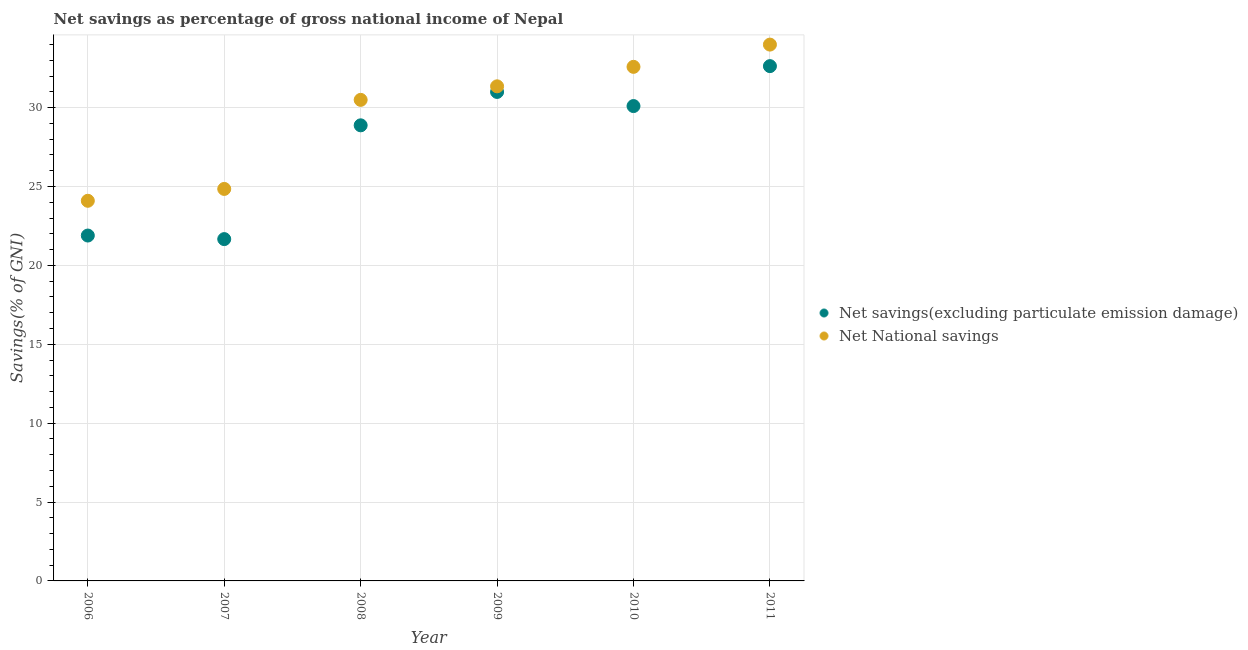How many different coloured dotlines are there?
Make the answer very short. 2. Is the number of dotlines equal to the number of legend labels?
Your answer should be compact. Yes. What is the net savings(excluding particulate emission damage) in 2007?
Ensure brevity in your answer.  21.66. Across all years, what is the maximum net national savings?
Keep it short and to the point. 33.99. Across all years, what is the minimum net savings(excluding particulate emission damage)?
Provide a succinct answer. 21.66. What is the total net savings(excluding particulate emission damage) in the graph?
Make the answer very short. 166.14. What is the difference between the net savings(excluding particulate emission damage) in 2007 and that in 2011?
Your answer should be very brief. -10.96. What is the difference between the net national savings in 2007 and the net savings(excluding particulate emission damage) in 2006?
Make the answer very short. 2.95. What is the average net national savings per year?
Your response must be concise. 29.56. In the year 2007, what is the difference between the net savings(excluding particulate emission damage) and net national savings?
Provide a succinct answer. -3.18. In how many years, is the net savings(excluding particulate emission damage) greater than 9 %?
Your answer should be compact. 6. What is the ratio of the net national savings in 2007 to that in 2010?
Your answer should be compact. 0.76. Is the difference between the net national savings in 2007 and 2009 greater than the difference between the net savings(excluding particulate emission damage) in 2007 and 2009?
Your answer should be compact. Yes. What is the difference between the highest and the second highest net national savings?
Provide a short and direct response. 1.41. What is the difference between the highest and the lowest net national savings?
Your answer should be compact. 9.9. In how many years, is the net savings(excluding particulate emission damage) greater than the average net savings(excluding particulate emission damage) taken over all years?
Your response must be concise. 4. Is the sum of the net national savings in 2008 and 2010 greater than the maximum net savings(excluding particulate emission damage) across all years?
Provide a short and direct response. Yes. Is the net national savings strictly greater than the net savings(excluding particulate emission damage) over the years?
Provide a short and direct response. Yes. Is the net national savings strictly less than the net savings(excluding particulate emission damage) over the years?
Ensure brevity in your answer.  No. Does the graph contain any zero values?
Your response must be concise. No. Does the graph contain grids?
Give a very brief answer. Yes. Where does the legend appear in the graph?
Your answer should be very brief. Center right. How are the legend labels stacked?
Provide a succinct answer. Vertical. What is the title of the graph?
Provide a succinct answer. Net savings as percentage of gross national income of Nepal. Does "Highest 20% of population" appear as one of the legend labels in the graph?
Offer a very short reply. No. What is the label or title of the X-axis?
Give a very brief answer. Year. What is the label or title of the Y-axis?
Your response must be concise. Savings(% of GNI). What is the Savings(% of GNI) of Net savings(excluding particulate emission damage) in 2006?
Keep it short and to the point. 21.89. What is the Savings(% of GNI) of Net National savings in 2006?
Offer a terse response. 24.09. What is the Savings(% of GNI) in Net savings(excluding particulate emission damage) in 2007?
Offer a very short reply. 21.66. What is the Savings(% of GNI) in Net National savings in 2007?
Give a very brief answer. 24.84. What is the Savings(% of GNI) in Net savings(excluding particulate emission damage) in 2008?
Make the answer very short. 28.87. What is the Savings(% of GNI) of Net National savings in 2008?
Keep it short and to the point. 30.49. What is the Savings(% of GNI) in Net savings(excluding particulate emission damage) in 2009?
Give a very brief answer. 30.99. What is the Savings(% of GNI) of Net National savings in 2009?
Give a very brief answer. 31.35. What is the Savings(% of GNI) in Net savings(excluding particulate emission damage) in 2010?
Ensure brevity in your answer.  30.1. What is the Savings(% of GNI) of Net National savings in 2010?
Ensure brevity in your answer.  32.58. What is the Savings(% of GNI) of Net savings(excluding particulate emission damage) in 2011?
Keep it short and to the point. 32.63. What is the Savings(% of GNI) in Net National savings in 2011?
Your answer should be compact. 33.99. Across all years, what is the maximum Savings(% of GNI) of Net savings(excluding particulate emission damage)?
Offer a very short reply. 32.63. Across all years, what is the maximum Savings(% of GNI) of Net National savings?
Your answer should be compact. 33.99. Across all years, what is the minimum Savings(% of GNI) in Net savings(excluding particulate emission damage)?
Keep it short and to the point. 21.66. Across all years, what is the minimum Savings(% of GNI) of Net National savings?
Your answer should be very brief. 24.09. What is the total Savings(% of GNI) in Net savings(excluding particulate emission damage) in the graph?
Ensure brevity in your answer.  166.14. What is the total Savings(% of GNI) of Net National savings in the graph?
Your answer should be very brief. 177.34. What is the difference between the Savings(% of GNI) of Net savings(excluding particulate emission damage) in 2006 and that in 2007?
Make the answer very short. 0.23. What is the difference between the Savings(% of GNI) in Net National savings in 2006 and that in 2007?
Your response must be concise. -0.75. What is the difference between the Savings(% of GNI) of Net savings(excluding particulate emission damage) in 2006 and that in 2008?
Make the answer very short. -6.99. What is the difference between the Savings(% of GNI) of Net National savings in 2006 and that in 2008?
Offer a very short reply. -6.4. What is the difference between the Savings(% of GNI) of Net savings(excluding particulate emission damage) in 2006 and that in 2009?
Make the answer very short. -9.1. What is the difference between the Savings(% of GNI) of Net National savings in 2006 and that in 2009?
Give a very brief answer. -7.25. What is the difference between the Savings(% of GNI) in Net savings(excluding particulate emission damage) in 2006 and that in 2010?
Provide a succinct answer. -8.21. What is the difference between the Savings(% of GNI) in Net National savings in 2006 and that in 2010?
Your answer should be very brief. -8.49. What is the difference between the Savings(% of GNI) in Net savings(excluding particulate emission damage) in 2006 and that in 2011?
Make the answer very short. -10.74. What is the difference between the Savings(% of GNI) in Net National savings in 2006 and that in 2011?
Your response must be concise. -9.9. What is the difference between the Savings(% of GNI) of Net savings(excluding particulate emission damage) in 2007 and that in 2008?
Provide a succinct answer. -7.21. What is the difference between the Savings(% of GNI) of Net National savings in 2007 and that in 2008?
Your answer should be very brief. -5.64. What is the difference between the Savings(% of GNI) of Net savings(excluding particulate emission damage) in 2007 and that in 2009?
Provide a succinct answer. -9.33. What is the difference between the Savings(% of GNI) of Net National savings in 2007 and that in 2009?
Keep it short and to the point. -6.5. What is the difference between the Savings(% of GNI) in Net savings(excluding particulate emission damage) in 2007 and that in 2010?
Make the answer very short. -8.43. What is the difference between the Savings(% of GNI) of Net National savings in 2007 and that in 2010?
Your answer should be compact. -7.74. What is the difference between the Savings(% of GNI) in Net savings(excluding particulate emission damage) in 2007 and that in 2011?
Make the answer very short. -10.96. What is the difference between the Savings(% of GNI) of Net National savings in 2007 and that in 2011?
Ensure brevity in your answer.  -9.15. What is the difference between the Savings(% of GNI) of Net savings(excluding particulate emission damage) in 2008 and that in 2009?
Provide a succinct answer. -2.12. What is the difference between the Savings(% of GNI) in Net National savings in 2008 and that in 2009?
Give a very brief answer. -0.86. What is the difference between the Savings(% of GNI) of Net savings(excluding particulate emission damage) in 2008 and that in 2010?
Offer a terse response. -1.22. What is the difference between the Savings(% of GNI) in Net National savings in 2008 and that in 2010?
Offer a very short reply. -2.09. What is the difference between the Savings(% of GNI) of Net savings(excluding particulate emission damage) in 2008 and that in 2011?
Give a very brief answer. -3.75. What is the difference between the Savings(% of GNI) in Net National savings in 2008 and that in 2011?
Make the answer very short. -3.5. What is the difference between the Savings(% of GNI) in Net savings(excluding particulate emission damage) in 2009 and that in 2010?
Your answer should be compact. 0.89. What is the difference between the Savings(% of GNI) in Net National savings in 2009 and that in 2010?
Offer a very short reply. -1.23. What is the difference between the Savings(% of GNI) in Net savings(excluding particulate emission damage) in 2009 and that in 2011?
Provide a succinct answer. -1.64. What is the difference between the Savings(% of GNI) in Net National savings in 2009 and that in 2011?
Your answer should be very brief. -2.64. What is the difference between the Savings(% of GNI) in Net savings(excluding particulate emission damage) in 2010 and that in 2011?
Make the answer very short. -2.53. What is the difference between the Savings(% of GNI) in Net National savings in 2010 and that in 2011?
Your answer should be very brief. -1.41. What is the difference between the Savings(% of GNI) in Net savings(excluding particulate emission damage) in 2006 and the Savings(% of GNI) in Net National savings in 2007?
Make the answer very short. -2.95. What is the difference between the Savings(% of GNI) of Net savings(excluding particulate emission damage) in 2006 and the Savings(% of GNI) of Net National savings in 2008?
Your answer should be very brief. -8.6. What is the difference between the Savings(% of GNI) in Net savings(excluding particulate emission damage) in 2006 and the Savings(% of GNI) in Net National savings in 2009?
Give a very brief answer. -9.46. What is the difference between the Savings(% of GNI) in Net savings(excluding particulate emission damage) in 2006 and the Savings(% of GNI) in Net National savings in 2010?
Your answer should be compact. -10.69. What is the difference between the Savings(% of GNI) in Net savings(excluding particulate emission damage) in 2006 and the Savings(% of GNI) in Net National savings in 2011?
Your answer should be compact. -12.1. What is the difference between the Savings(% of GNI) in Net savings(excluding particulate emission damage) in 2007 and the Savings(% of GNI) in Net National savings in 2008?
Your answer should be very brief. -8.82. What is the difference between the Savings(% of GNI) in Net savings(excluding particulate emission damage) in 2007 and the Savings(% of GNI) in Net National savings in 2009?
Your answer should be compact. -9.68. What is the difference between the Savings(% of GNI) in Net savings(excluding particulate emission damage) in 2007 and the Savings(% of GNI) in Net National savings in 2010?
Provide a short and direct response. -10.92. What is the difference between the Savings(% of GNI) of Net savings(excluding particulate emission damage) in 2007 and the Savings(% of GNI) of Net National savings in 2011?
Ensure brevity in your answer.  -12.33. What is the difference between the Savings(% of GNI) of Net savings(excluding particulate emission damage) in 2008 and the Savings(% of GNI) of Net National savings in 2009?
Your response must be concise. -2.47. What is the difference between the Savings(% of GNI) of Net savings(excluding particulate emission damage) in 2008 and the Savings(% of GNI) of Net National savings in 2010?
Provide a succinct answer. -3.71. What is the difference between the Savings(% of GNI) in Net savings(excluding particulate emission damage) in 2008 and the Savings(% of GNI) in Net National savings in 2011?
Your response must be concise. -5.12. What is the difference between the Savings(% of GNI) in Net savings(excluding particulate emission damage) in 2009 and the Savings(% of GNI) in Net National savings in 2010?
Make the answer very short. -1.59. What is the difference between the Savings(% of GNI) in Net savings(excluding particulate emission damage) in 2009 and the Savings(% of GNI) in Net National savings in 2011?
Offer a very short reply. -3. What is the difference between the Savings(% of GNI) in Net savings(excluding particulate emission damage) in 2010 and the Savings(% of GNI) in Net National savings in 2011?
Your answer should be compact. -3.9. What is the average Savings(% of GNI) of Net savings(excluding particulate emission damage) per year?
Provide a succinct answer. 27.69. What is the average Savings(% of GNI) of Net National savings per year?
Make the answer very short. 29.56. In the year 2006, what is the difference between the Savings(% of GNI) of Net savings(excluding particulate emission damage) and Savings(% of GNI) of Net National savings?
Make the answer very short. -2.2. In the year 2007, what is the difference between the Savings(% of GNI) in Net savings(excluding particulate emission damage) and Savings(% of GNI) in Net National savings?
Your answer should be very brief. -3.18. In the year 2008, what is the difference between the Savings(% of GNI) in Net savings(excluding particulate emission damage) and Savings(% of GNI) in Net National savings?
Ensure brevity in your answer.  -1.61. In the year 2009, what is the difference between the Savings(% of GNI) of Net savings(excluding particulate emission damage) and Savings(% of GNI) of Net National savings?
Provide a short and direct response. -0.36. In the year 2010, what is the difference between the Savings(% of GNI) of Net savings(excluding particulate emission damage) and Savings(% of GNI) of Net National savings?
Give a very brief answer. -2.49. In the year 2011, what is the difference between the Savings(% of GNI) in Net savings(excluding particulate emission damage) and Savings(% of GNI) in Net National savings?
Provide a short and direct response. -1.36. What is the ratio of the Savings(% of GNI) of Net savings(excluding particulate emission damage) in 2006 to that in 2007?
Give a very brief answer. 1.01. What is the ratio of the Savings(% of GNI) of Net National savings in 2006 to that in 2007?
Offer a very short reply. 0.97. What is the ratio of the Savings(% of GNI) in Net savings(excluding particulate emission damage) in 2006 to that in 2008?
Give a very brief answer. 0.76. What is the ratio of the Savings(% of GNI) in Net National savings in 2006 to that in 2008?
Your answer should be compact. 0.79. What is the ratio of the Savings(% of GNI) of Net savings(excluding particulate emission damage) in 2006 to that in 2009?
Your response must be concise. 0.71. What is the ratio of the Savings(% of GNI) of Net National savings in 2006 to that in 2009?
Offer a very short reply. 0.77. What is the ratio of the Savings(% of GNI) of Net savings(excluding particulate emission damage) in 2006 to that in 2010?
Offer a very short reply. 0.73. What is the ratio of the Savings(% of GNI) in Net National savings in 2006 to that in 2010?
Provide a succinct answer. 0.74. What is the ratio of the Savings(% of GNI) of Net savings(excluding particulate emission damage) in 2006 to that in 2011?
Provide a succinct answer. 0.67. What is the ratio of the Savings(% of GNI) in Net National savings in 2006 to that in 2011?
Keep it short and to the point. 0.71. What is the ratio of the Savings(% of GNI) in Net savings(excluding particulate emission damage) in 2007 to that in 2008?
Your answer should be compact. 0.75. What is the ratio of the Savings(% of GNI) of Net National savings in 2007 to that in 2008?
Offer a very short reply. 0.81. What is the ratio of the Savings(% of GNI) in Net savings(excluding particulate emission damage) in 2007 to that in 2009?
Keep it short and to the point. 0.7. What is the ratio of the Savings(% of GNI) in Net National savings in 2007 to that in 2009?
Ensure brevity in your answer.  0.79. What is the ratio of the Savings(% of GNI) of Net savings(excluding particulate emission damage) in 2007 to that in 2010?
Provide a succinct answer. 0.72. What is the ratio of the Savings(% of GNI) in Net National savings in 2007 to that in 2010?
Keep it short and to the point. 0.76. What is the ratio of the Savings(% of GNI) of Net savings(excluding particulate emission damage) in 2007 to that in 2011?
Your answer should be very brief. 0.66. What is the ratio of the Savings(% of GNI) in Net National savings in 2007 to that in 2011?
Give a very brief answer. 0.73. What is the ratio of the Savings(% of GNI) of Net savings(excluding particulate emission damage) in 2008 to that in 2009?
Give a very brief answer. 0.93. What is the ratio of the Savings(% of GNI) of Net National savings in 2008 to that in 2009?
Keep it short and to the point. 0.97. What is the ratio of the Savings(% of GNI) of Net savings(excluding particulate emission damage) in 2008 to that in 2010?
Your response must be concise. 0.96. What is the ratio of the Savings(% of GNI) of Net National savings in 2008 to that in 2010?
Your answer should be compact. 0.94. What is the ratio of the Savings(% of GNI) of Net savings(excluding particulate emission damage) in 2008 to that in 2011?
Make the answer very short. 0.89. What is the ratio of the Savings(% of GNI) in Net National savings in 2008 to that in 2011?
Provide a succinct answer. 0.9. What is the ratio of the Savings(% of GNI) of Net savings(excluding particulate emission damage) in 2009 to that in 2010?
Provide a short and direct response. 1.03. What is the ratio of the Savings(% of GNI) in Net National savings in 2009 to that in 2010?
Offer a terse response. 0.96. What is the ratio of the Savings(% of GNI) of Net savings(excluding particulate emission damage) in 2009 to that in 2011?
Provide a succinct answer. 0.95. What is the ratio of the Savings(% of GNI) in Net National savings in 2009 to that in 2011?
Provide a succinct answer. 0.92. What is the ratio of the Savings(% of GNI) in Net savings(excluding particulate emission damage) in 2010 to that in 2011?
Your response must be concise. 0.92. What is the ratio of the Savings(% of GNI) in Net National savings in 2010 to that in 2011?
Your response must be concise. 0.96. What is the difference between the highest and the second highest Savings(% of GNI) in Net savings(excluding particulate emission damage)?
Provide a succinct answer. 1.64. What is the difference between the highest and the second highest Savings(% of GNI) in Net National savings?
Ensure brevity in your answer.  1.41. What is the difference between the highest and the lowest Savings(% of GNI) in Net savings(excluding particulate emission damage)?
Keep it short and to the point. 10.96. What is the difference between the highest and the lowest Savings(% of GNI) of Net National savings?
Give a very brief answer. 9.9. 